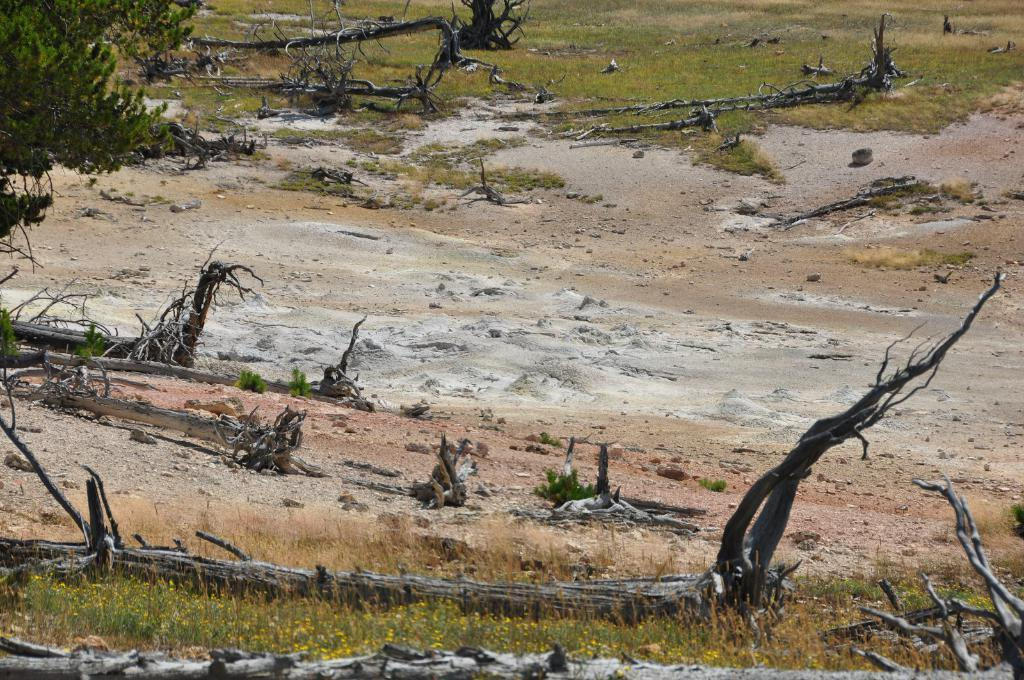What type of vegetation can be seen in the image? There are plants and grass visible in the image. What other natural elements can be seen in the image? There are barks visible in the image. What type of terrain is visible in the image? There is land visible in the image. What type of drain can be seen in the image? There is no drain present in the image. What type of discovery was made in the image? There is no discovery mentioned or depicted in the image. 